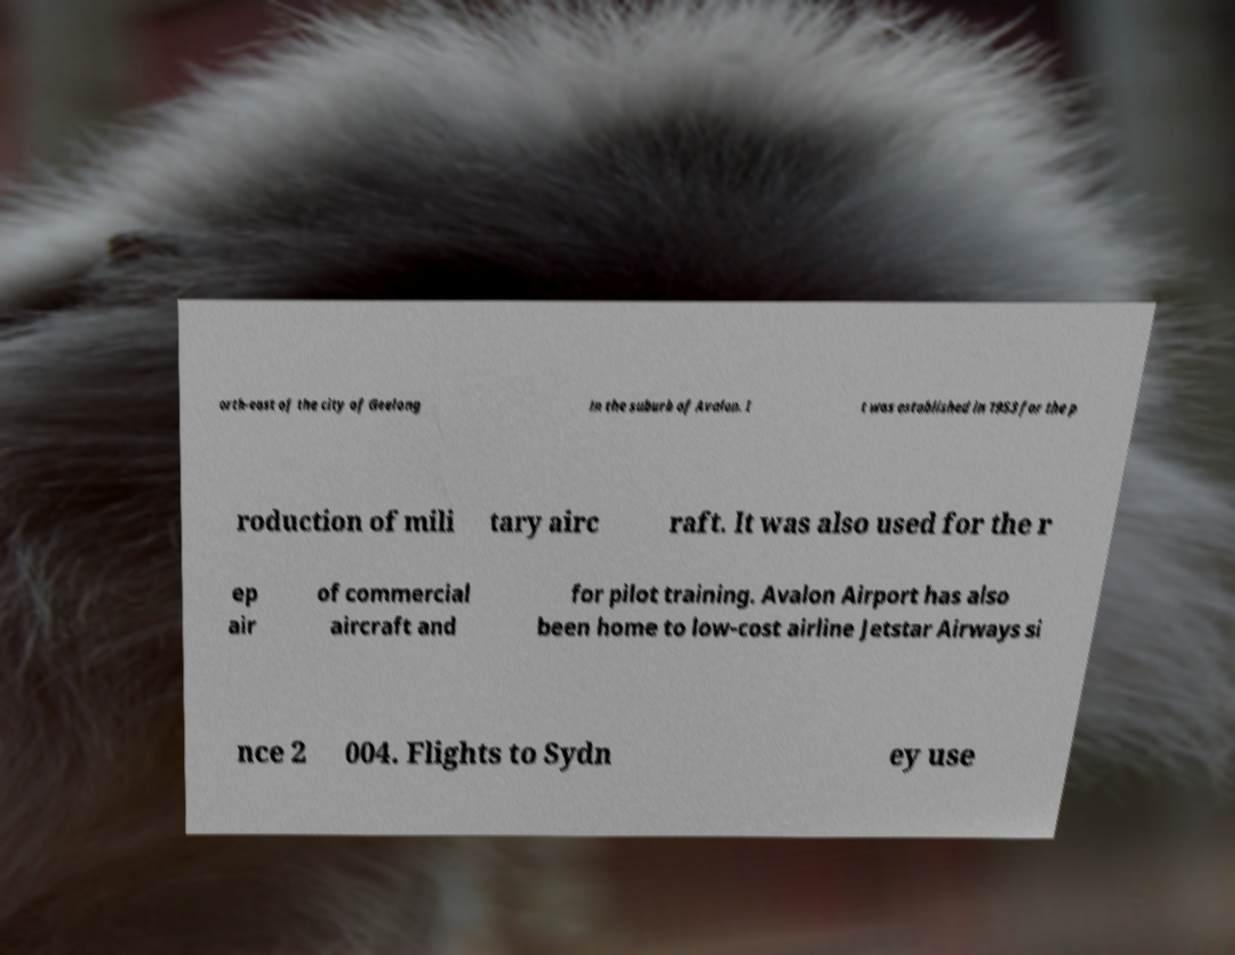What messages or text are displayed in this image? I need them in a readable, typed format. orth-east of the city of Geelong in the suburb of Avalon. I t was established in 1953 for the p roduction of mili tary airc raft. It was also used for the r ep air of commercial aircraft and for pilot training. Avalon Airport has also been home to low-cost airline Jetstar Airways si nce 2 004. Flights to Sydn ey use 